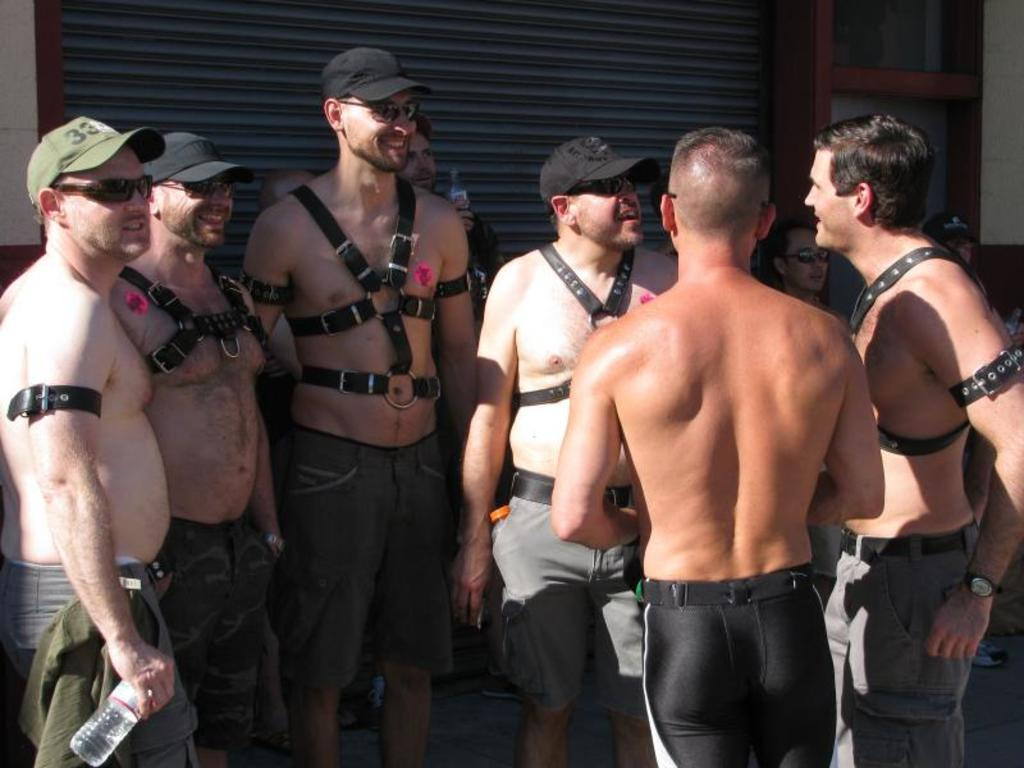What is happening in the image? There are people standing in the image. Can you describe any specific features or objects in the image? Yes, there is a shutter visible in the image. What type of dress is the maid wearing in the image? There is no maid or dress present in the image. 